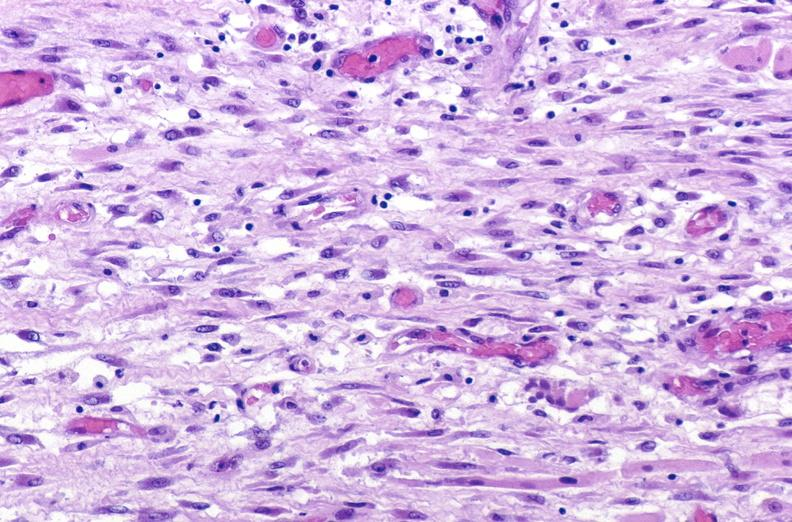does this image show tracheotomy site, granulation tissue?
Answer the question using a single word or phrase. Yes 